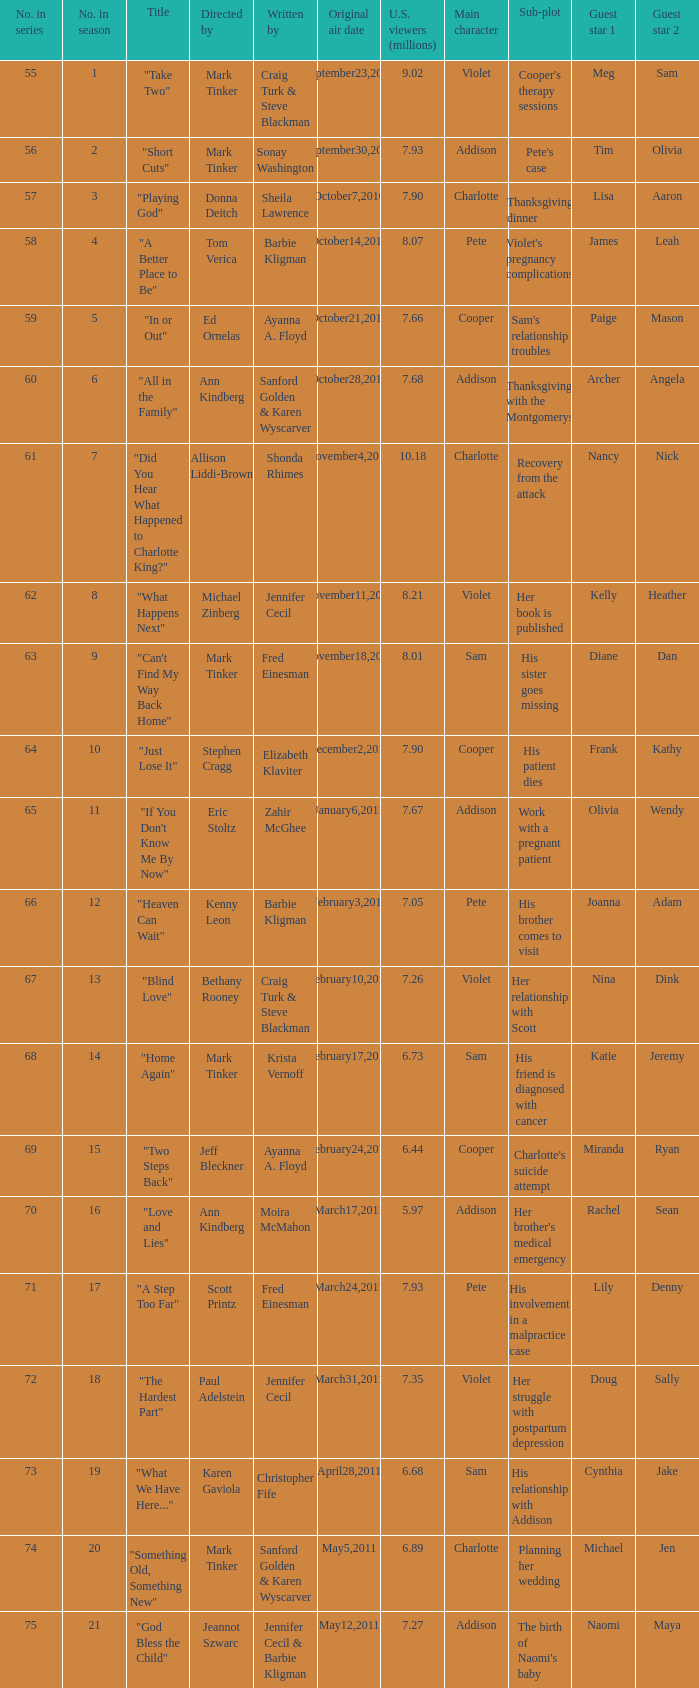What is the earliest numbered episode of the season? 1.0. 